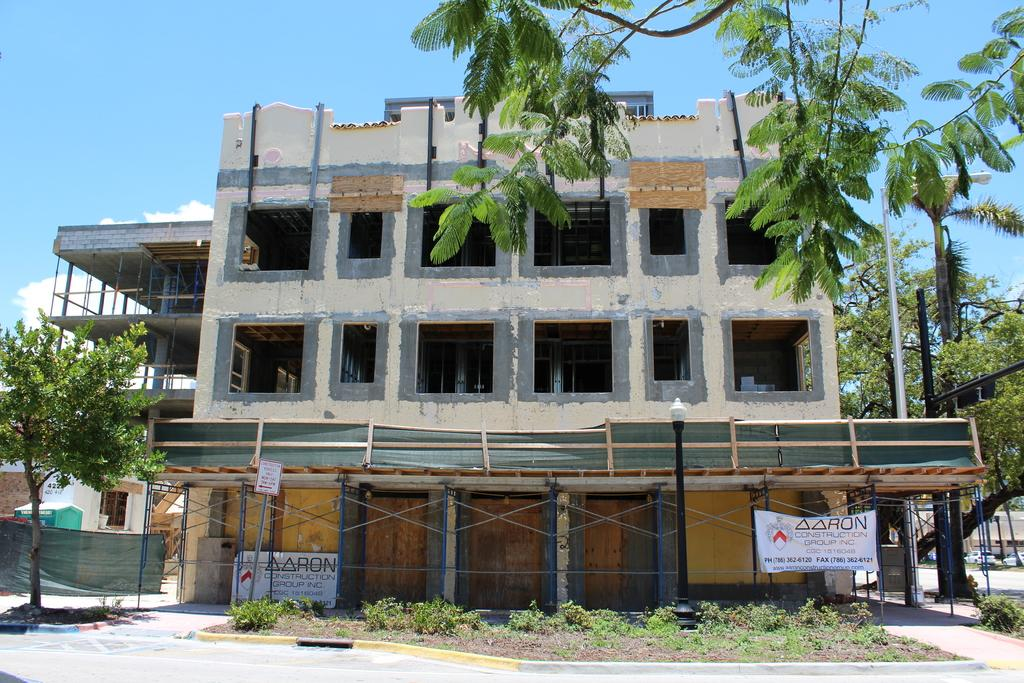What is the main subject of the image? The main subject of the image is a building under construction. What can be seen in the background of the image? There are trees in the image. Is there any other object or vehicle present in the image? Yes, there is a vehicle in the image. What type of advice can be seen written on the building in the image? There is no advice written on the building in the image; it is a building under construction. What kind of toy is being played with by the dog in the image? There is no dog or toy present in the image. 